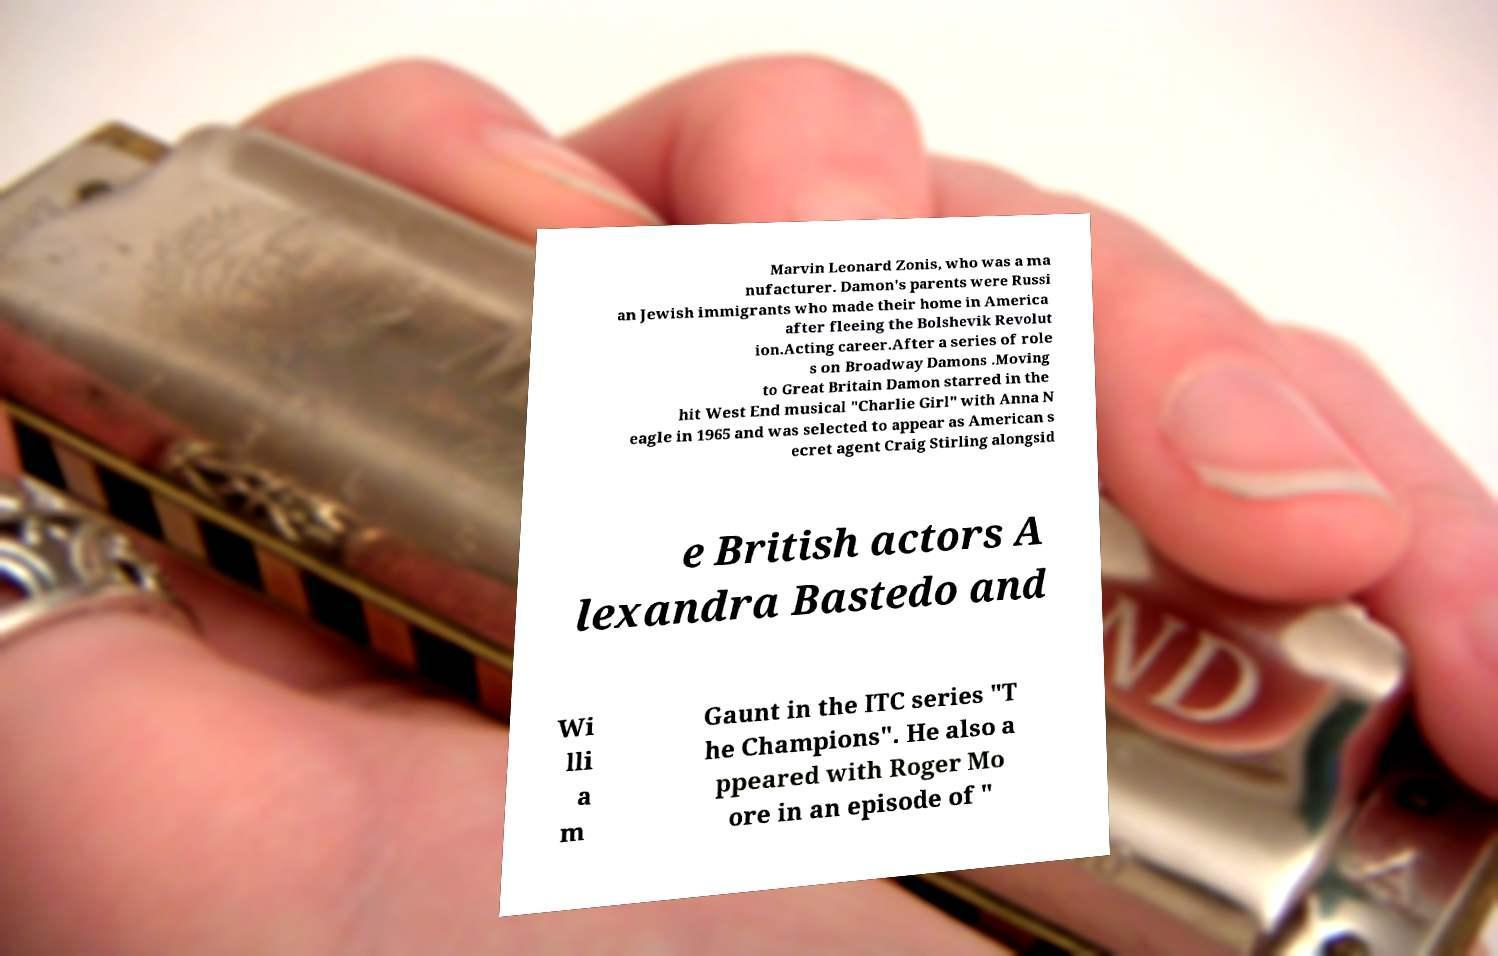For documentation purposes, I need the text within this image transcribed. Could you provide that? Marvin Leonard Zonis, who was a ma nufacturer. Damon's parents were Russi an Jewish immigrants who made their home in America after fleeing the Bolshevik Revolut ion.Acting career.After a series of role s on Broadway Damons .Moving to Great Britain Damon starred in the hit West End musical "Charlie Girl" with Anna N eagle in 1965 and was selected to appear as American s ecret agent Craig Stirling alongsid e British actors A lexandra Bastedo and Wi lli a m Gaunt in the ITC series "T he Champions". He also a ppeared with Roger Mo ore in an episode of " 